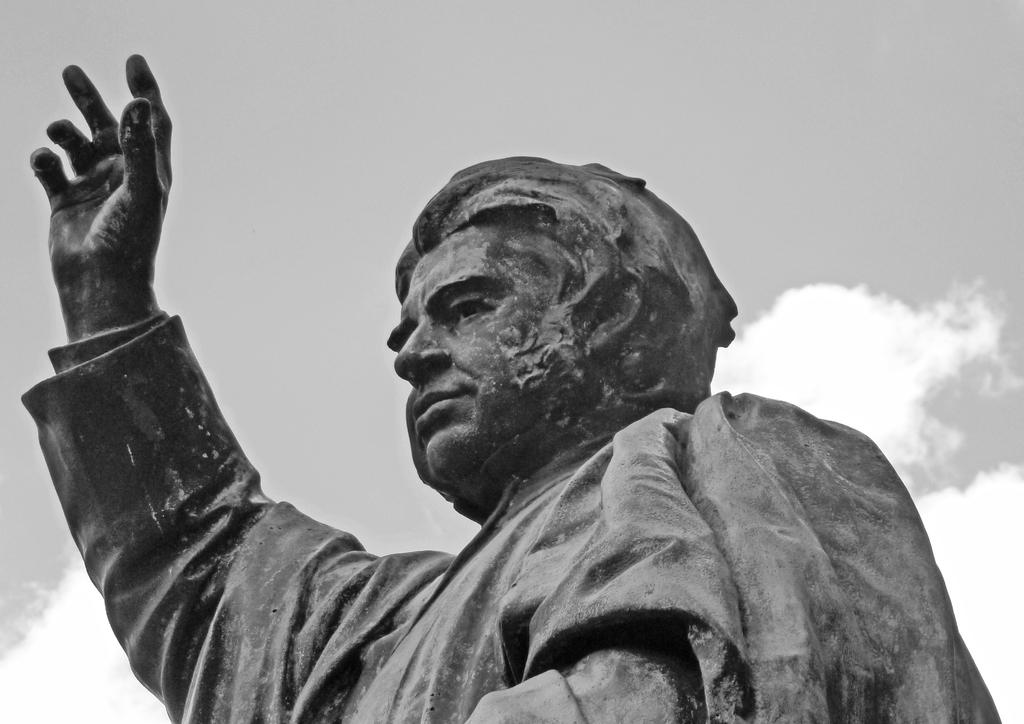What is the main subject in the image? There is a statue in the image. What can be seen in the background of the image? The sky is visible in the background of the image. What type of zipper can be seen on the statue in the image? There is no zipper present on the statue in the image. How many nails are used to hold the statue together in the image? The image does not provide information about the construction of the statue, so we cannot determine the number of nails used. 